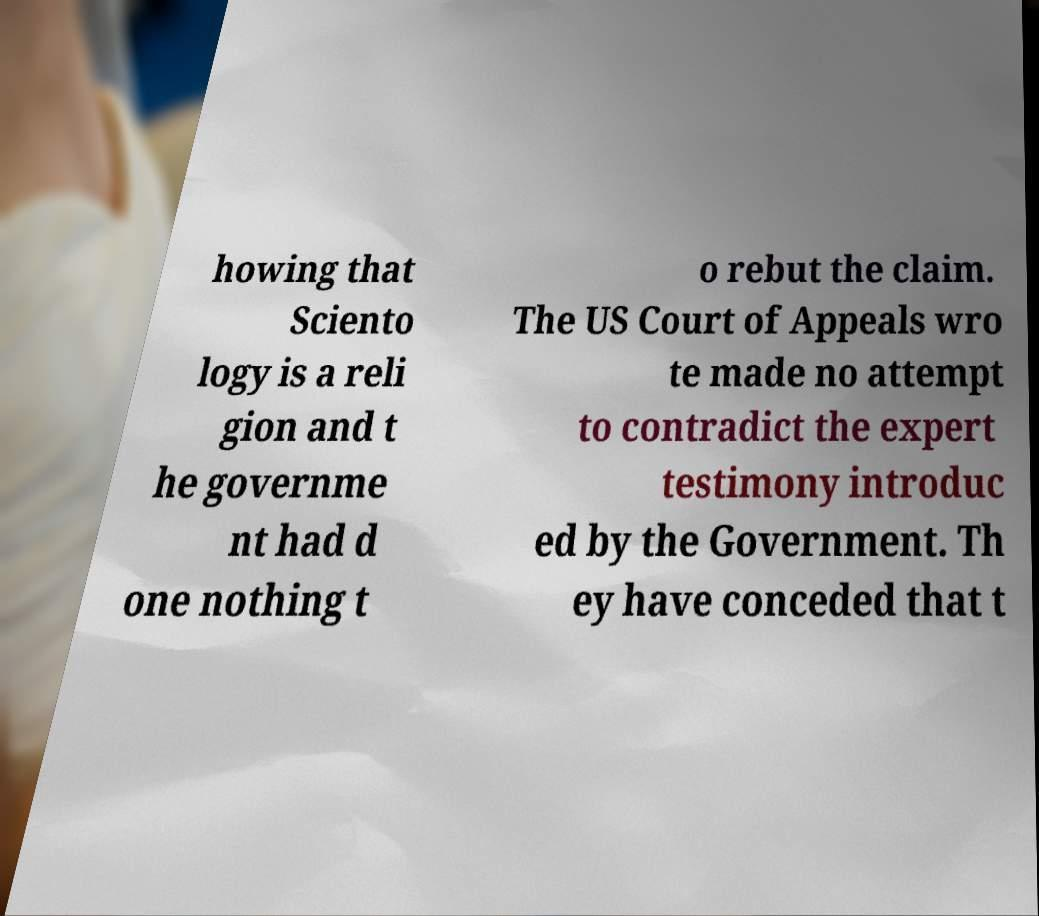Can you accurately transcribe the text from the provided image for me? howing that Sciento logy is a reli gion and t he governme nt had d one nothing t o rebut the claim. The US Court of Appeals wro te made no attempt to contradict the expert testimony introduc ed by the Government. Th ey have conceded that t 